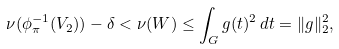Convert formula to latex. <formula><loc_0><loc_0><loc_500><loc_500>\nu ( \phi _ { \pi } ^ { - 1 } ( V _ { 2 } ) ) - \delta < \nu ( W ) \leq \int _ { G } g ( t ) ^ { 2 } \, d t = \| g \| _ { 2 } ^ { 2 } ,</formula> 